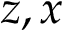Convert formula to latex. <formula><loc_0><loc_0><loc_500><loc_500>z , x</formula> 